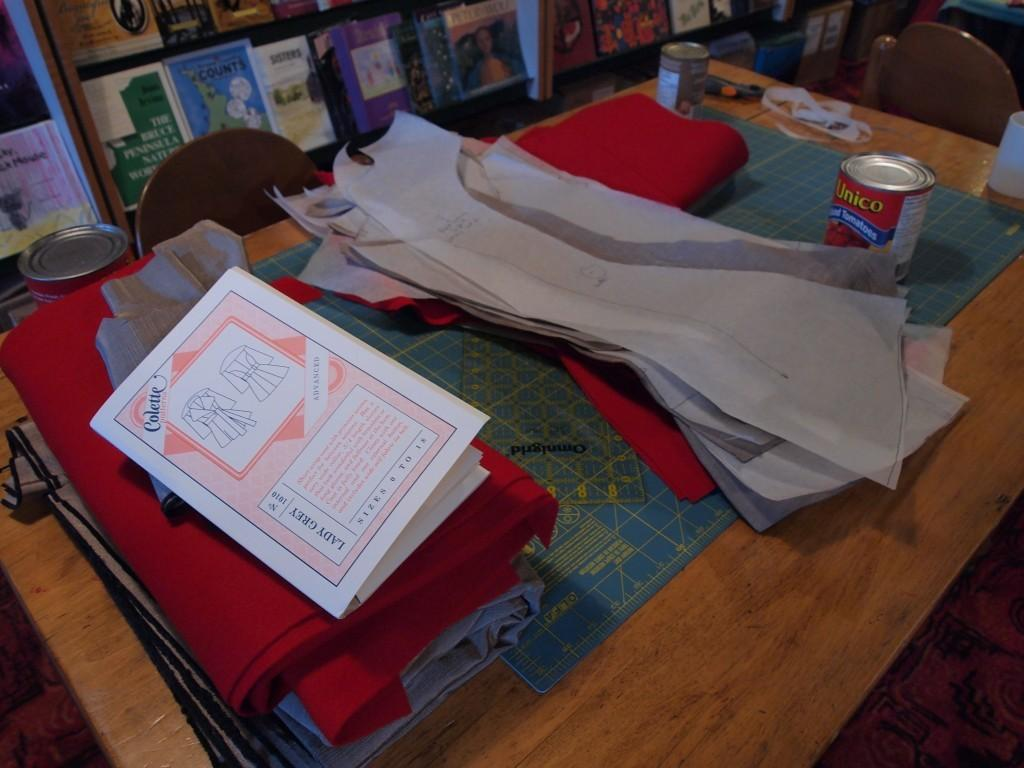What color is the item on the table in the image? There is a blue item on the table. What else can be seen on the table besides the blue item? There are papers, a tin, a red cloth, and a book on the table. What is the background of the image? In the background, there is a cupboard with many books. How many eggs are visible in the image? There are no eggs present in the image. What type of transport is shown in the image? There is no transport visible in the image. 